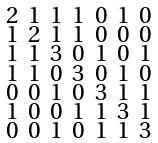Convert formula to latex. <formula><loc_0><loc_0><loc_500><loc_500>\begin{smallmatrix} 2 & 1 & 1 & 1 & 0 & 1 & 0 \\ 1 & 2 & 1 & 1 & 0 & 0 & 0 \\ 1 & 1 & 3 & 0 & 1 & 0 & 1 \\ 1 & 1 & 0 & 3 & 0 & 1 & 0 \\ 0 & 0 & 1 & 0 & 3 & 1 & 1 \\ 1 & 0 & 0 & 1 & 1 & 3 & 1 \\ 0 & 0 & 1 & 0 & 1 & 1 & 3 \end{smallmatrix}</formula> 